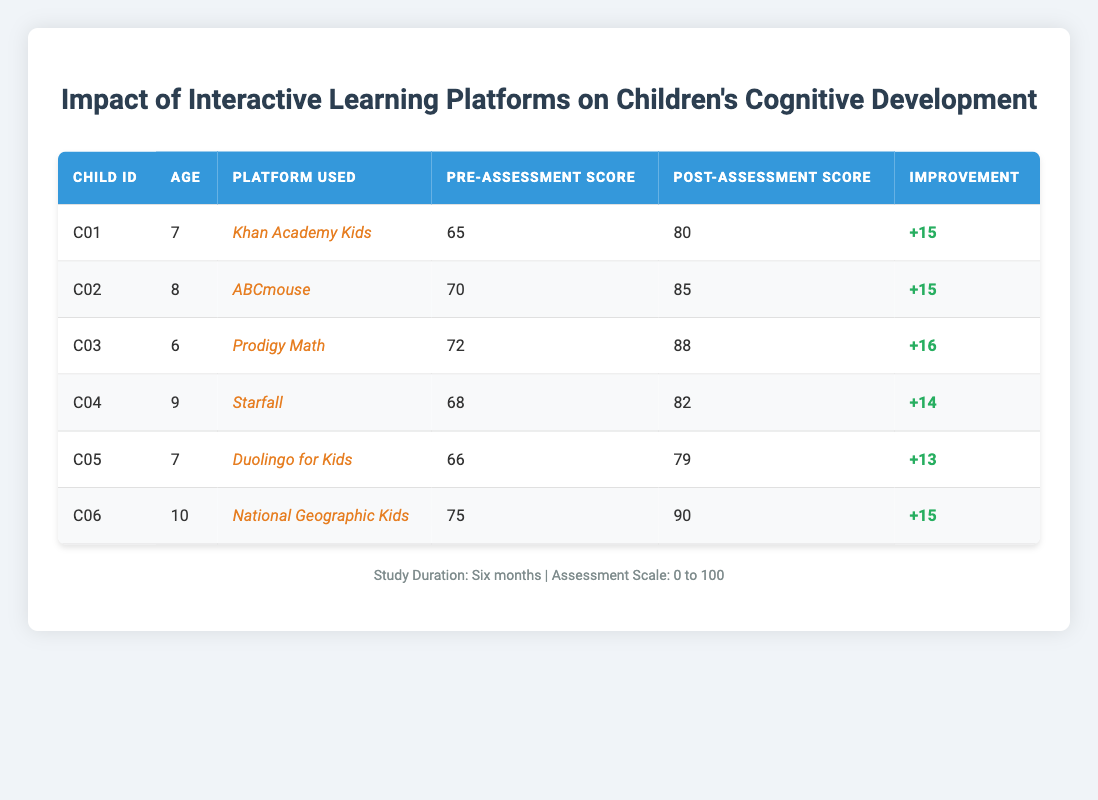What is the pre-assessment score of the child using ABCmouse? The pre-assessment score is listed in the table under the "Pre-Assessment Score" column for the child with the ID C02, who uses ABCmouse. The value is 70.
Answer: 70 What platform did the child with the highest improvement use? To find the child with the highest improvement, we compare the "Improvement" column values. The maximum improvement is 16, which corresponds to the child C03 using Prodigy Math.
Answer: Prodigy Math What is the average post-assessment score for all children? First, we sum the post-assessment scores: 80 + 85 + 88 + 82 + 79 + 90 = 504. There are 6 children, so the average is 504/6 = 84.
Answer: 84 Is there any child who had an improvement of more than 15 points? We check the "Improvement" column for any values greater than 15. The child C03 had an improvement of 16, confirming there is at least one child who meets the condition.
Answer: Yes What is the age of the child who scored the lowest post-assessment score? Looking at the "Post-Assessment Score" column, the lowest score is 79 associated with child C05. The age for C05 is 7 from the "Age" column.
Answer: 7 What is the total improvement across all children? We calculate the total improvement by summing the "Improvement" values: 15 + 15 + 16 + 14 + 13 + 15 = 88.
Answer: 88 Which platform showed no child with less than a 13-point improvement? By reviewing the improvement scores, the minimum improvement score for each platform shows that Duolingo for Kids has the lowest improvement of 13. Therefore, no other platform meets the criterion as all others had higher scores.
Answer: Duolingo for Kids How many children aged 8 improved their scores by more than 14 points? Checking the table, the only child aged 8 is C02 with an improvement of 15. Thus, there is one child aged 8 who meets the requirement.
Answer: 1 What is the difference between the highest and lowest pre-assessment scores? The highest pre-assessment score is 75 (from C06) and the lowest is 65 (from C01). The difference is calculated as 75 - 65 = 10.
Answer: 10 